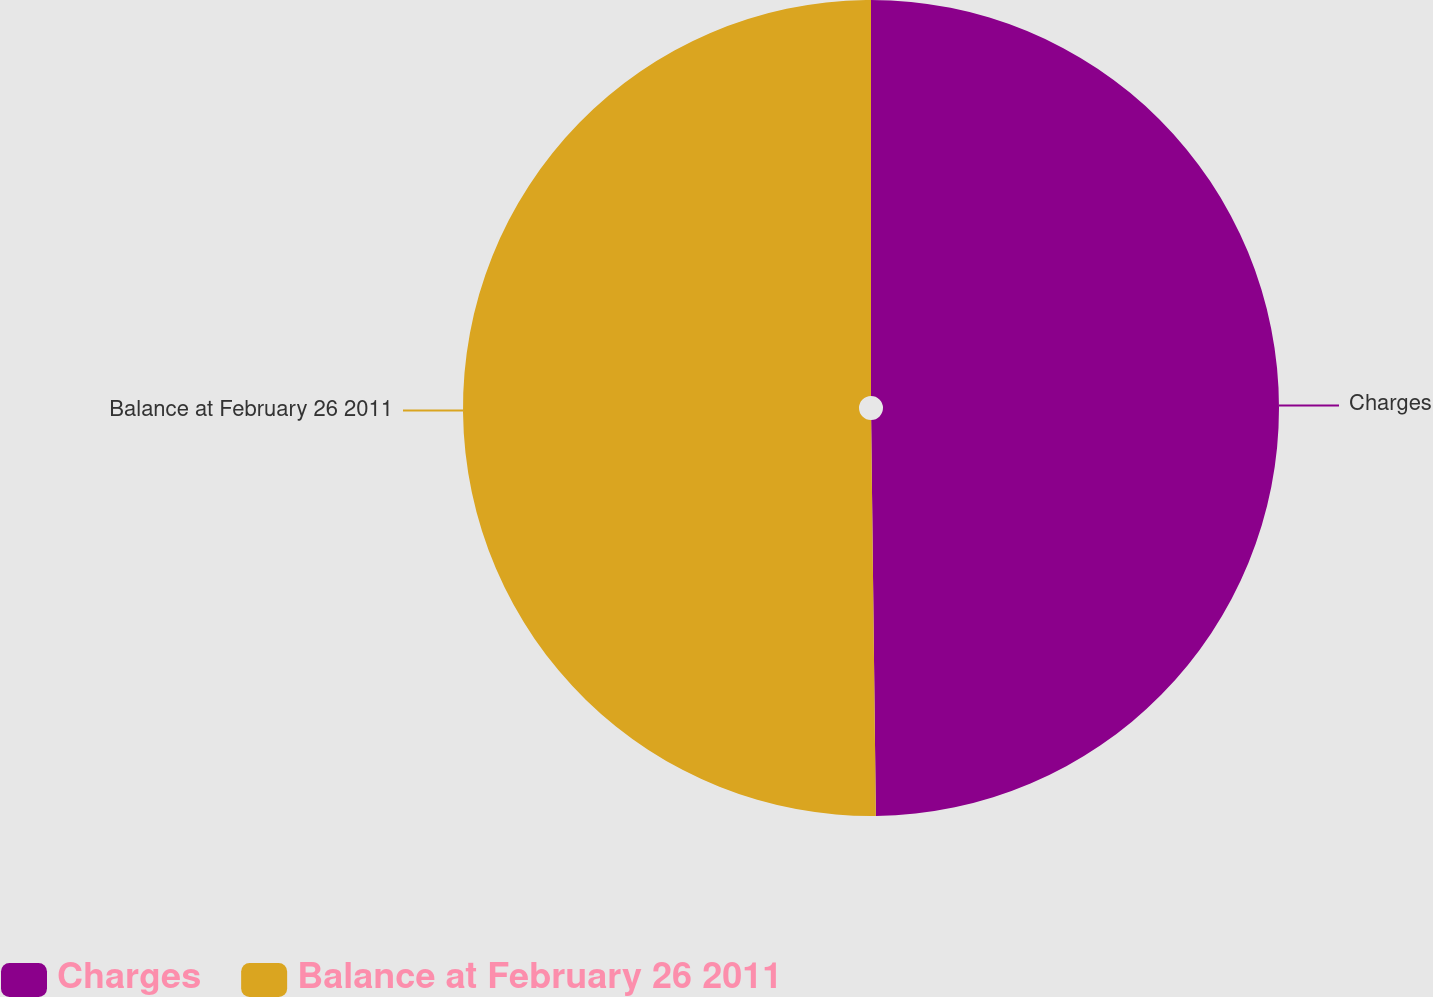Convert chart to OTSL. <chart><loc_0><loc_0><loc_500><loc_500><pie_chart><fcel>Charges<fcel>Balance at February 26 2011<nl><fcel>49.81%<fcel>50.19%<nl></chart> 